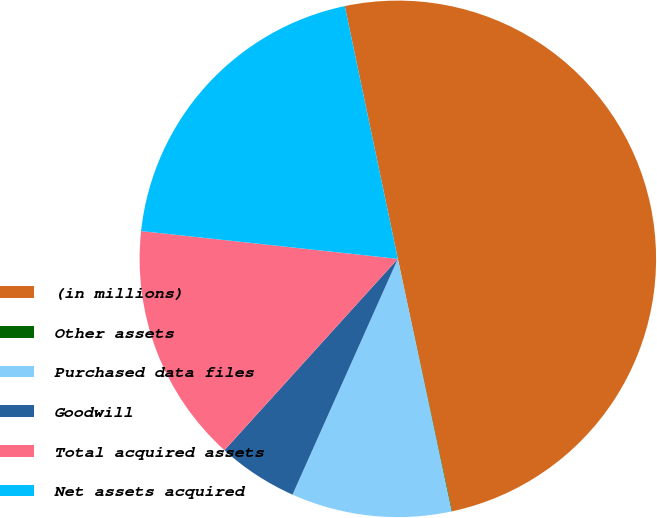Convert chart. <chart><loc_0><loc_0><loc_500><loc_500><pie_chart><fcel>(in millions)<fcel>Other assets<fcel>Purchased data files<fcel>Goodwill<fcel>Total acquired assets<fcel>Net assets acquired<nl><fcel>49.92%<fcel>0.04%<fcel>10.02%<fcel>5.03%<fcel>15.0%<fcel>19.99%<nl></chart> 